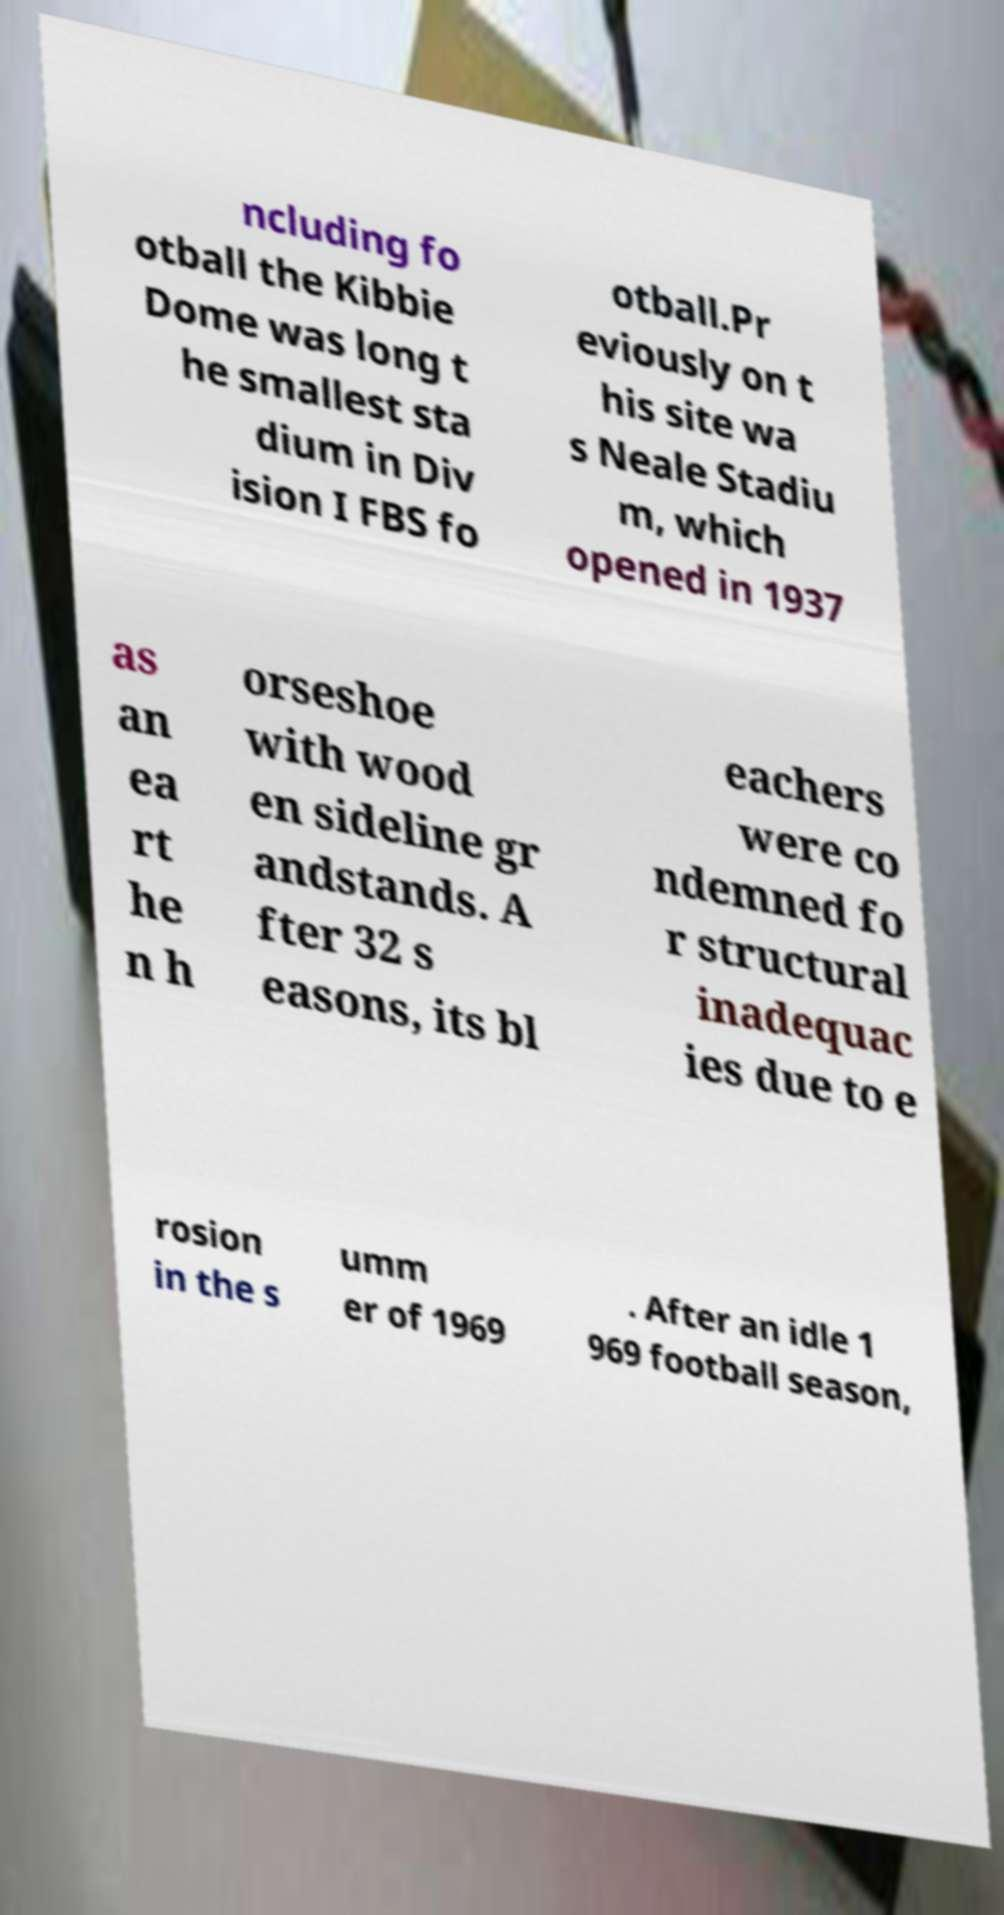Please read and relay the text visible in this image. What does it say? ncluding fo otball the Kibbie Dome was long t he smallest sta dium in Div ision I FBS fo otball.Pr eviously on t his site wa s Neale Stadiu m, which opened in 1937 as an ea rt he n h orseshoe with wood en sideline gr andstands. A fter 32 s easons, its bl eachers were co ndemned fo r structural inadequac ies due to e rosion in the s umm er of 1969 . After an idle 1 969 football season, 